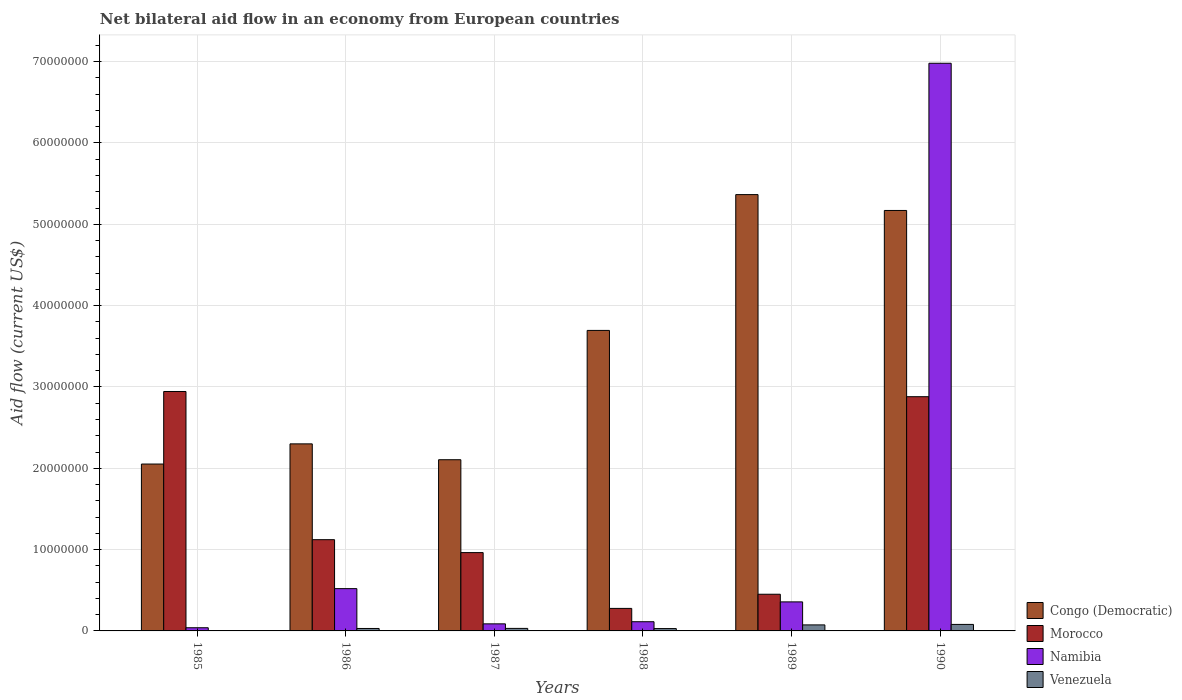How many different coloured bars are there?
Make the answer very short. 4. Are the number of bars per tick equal to the number of legend labels?
Make the answer very short. Yes. Are the number of bars on each tick of the X-axis equal?
Give a very brief answer. Yes. How many bars are there on the 1st tick from the left?
Give a very brief answer. 4. How many bars are there on the 1st tick from the right?
Your response must be concise. 4. What is the label of the 2nd group of bars from the left?
Provide a succinct answer. 1986. In how many cases, is the number of bars for a given year not equal to the number of legend labels?
Provide a short and direct response. 0. What is the net bilateral aid flow in Congo (Democratic) in 1987?
Provide a short and direct response. 2.10e+07. Across all years, what is the maximum net bilateral aid flow in Namibia?
Keep it short and to the point. 6.98e+07. In which year was the net bilateral aid flow in Venezuela maximum?
Offer a terse response. 1990. In which year was the net bilateral aid flow in Congo (Democratic) minimum?
Ensure brevity in your answer.  1985. What is the total net bilateral aid flow in Congo (Democratic) in the graph?
Offer a terse response. 2.07e+08. What is the difference between the net bilateral aid flow in Namibia in 1989 and that in 1990?
Offer a very short reply. -6.62e+07. What is the difference between the net bilateral aid flow in Congo (Democratic) in 1986 and the net bilateral aid flow in Namibia in 1990?
Your answer should be very brief. -4.68e+07. What is the average net bilateral aid flow in Congo (Democratic) per year?
Your answer should be compact. 3.45e+07. In the year 1989, what is the difference between the net bilateral aid flow in Congo (Democratic) and net bilateral aid flow in Venezuela?
Keep it short and to the point. 5.29e+07. In how many years, is the net bilateral aid flow in Namibia greater than 62000000 US$?
Offer a very short reply. 1. What is the ratio of the net bilateral aid flow in Namibia in 1985 to that in 1988?
Give a very brief answer. 0.35. Is the net bilateral aid flow in Namibia in 1987 less than that in 1990?
Ensure brevity in your answer.  Yes. What is the difference between the highest and the second highest net bilateral aid flow in Namibia?
Keep it short and to the point. 6.46e+07. What is the difference between the highest and the lowest net bilateral aid flow in Congo (Democratic)?
Keep it short and to the point. 3.31e+07. Is it the case that in every year, the sum of the net bilateral aid flow in Morocco and net bilateral aid flow in Congo (Democratic) is greater than the sum of net bilateral aid flow in Namibia and net bilateral aid flow in Venezuela?
Offer a terse response. Yes. What does the 4th bar from the left in 1990 represents?
Offer a very short reply. Venezuela. What does the 2nd bar from the right in 1987 represents?
Your answer should be compact. Namibia. Is it the case that in every year, the sum of the net bilateral aid flow in Venezuela and net bilateral aid flow in Morocco is greater than the net bilateral aid flow in Namibia?
Keep it short and to the point. No. Are all the bars in the graph horizontal?
Give a very brief answer. No. What is the difference between two consecutive major ticks on the Y-axis?
Offer a terse response. 1.00e+07. Are the values on the major ticks of Y-axis written in scientific E-notation?
Your answer should be very brief. No. Does the graph contain any zero values?
Give a very brief answer. No. Does the graph contain grids?
Provide a succinct answer. Yes. Where does the legend appear in the graph?
Keep it short and to the point. Bottom right. How many legend labels are there?
Offer a very short reply. 4. How are the legend labels stacked?
Your response must be concise. Vertical. What is the title of the graph?
Provide a succinct answer. Net bilateral aid flow in an economy from European countries. What is the label or title of the X-axis?
Your answer should be compact. Years. What is the Aid flow (current US$) of Congo (Democratic) in 1985?
Provide a succinct answer. 2.05e+07. What is the Aid flow (current US$) in Morocco in 1985?
Ensure brevity in your answer.  2.94e+07. What is the Aid flow (current US$) of Namibia in 1985?
Give a very brief answer. 3.90e+05. What is the Aid flow (current US$) of Congo (Democratic) in 1986?
Your response must be concise. 2.30e+07. What is the Aid flow (current US$) in Morocco in 1986?
Provide a succinct answer. 1.12e+07. What is the Aid flow (current US$) of Namibia in 1986?
Provide a succinct answer. 5.20e+06. What is the Aid flow (current US$) in Venezuela in 1986?
Your answer should be very brief. 3.00e+05. What is the Aid flow (current US$) of Congo (Democratic) in 1987?
Your answer should be compact. 2.10e+07. What is the Aid flow (current US$) of Morocco in 1987?
Make the answer very short. 9.63e+06. What is the Aid flow (current US$) of Namibia in 1987?
Provide a succinct answer. 8.70e+05. What is the Aid flow (current US$) in Congo (Democratic) in 1988?
Your answer should be compact. 3.70e+07. What is the Aid flow (current US$) of Morocco in 1988?
Your answer should be very brief. 2.77e+06. What is the Aid flow (current US$) of Namibia in 1988?
Make the answer very short. 1.13e+06. What is the Aid flow (current US$) in Congo (Democratic) in 1989?
Provide a succinct answer. 5.36e+07. What is the Aid flow (current US$) in Morocco in 1989?
Offer a terse response. 4.51e+06. What is the Aid flow (current US$) of Namibia in 1989?
Keep it short and to the point. 3.57e+06. What is the Aid flow (current US$) of Venezuela in 1989?
Your response must be concise. 7.40e+05. What is the Aid flow (current US$) in Congo (Democratic) in 1990?
Give a very brief answer. 5.17e+07. What is the Aid flow (current US$) of Morocco in 1990?
Keep it short and to the point. 2.88e+07. What is the Aid flow (current US$) in Namibia in 1990?
Ensure brevity in your answer.  6.98e+07. Across all years, what is the maximum Aid flow (current US$) of Congo (Democratic)?
Provide a succinct answer. 5.36e+07. Across all years, what is the maximum Aid flow (current US$) in Morocco?
Offer a very short reply. 2.94e+07. Across all years, what is the maximum Aid flow (current US$) of Namibia?
Provide a short and direct response. 6.98e+07. Across all years, what is the minimum Aid flow (current US$) in Congo (Democratic)?
Your answer should be very brief. 2.05e+07. Across all years, what is the minimum Aid flow (current US$) in Morocco?
Keep it short and to the point. 2.77e+06. Across all years, what is the minimum Aid flow (current US$) in Namibia?
Provide a succinct answer. 3.90e+05. What is the total Aid flow (current US$) of Congo (Democratic) in the graph?
Your answer should be compact. 2.07e+08. What is the total Aid flow (current US$) of Morocco in the graph?
Keep it short and to the point. 8.64e+07. What is the total Aid flow (current US$) in Namibia in the graph?
Offer a very short reply. 8.10e+07. What is the total Aid flow (current US$) in Venezuela in the graph?
Provide a succinct answer. 2.46e+06. What is the difference between the Aid flow (current US$) in Congo (Democratic) in 1985 and that in 1986?
Your response must be concise. -2.48e+06. What is the difference between the Aid flow (current US$) in Morocco in 1985 and that in 1986?
Give a very brief answer. 1.82e+07. What is the difference between the Aid flow (current US$) of Namibia in 1985 and that in 1986?
Offer a very short reply. -4.81e+06. What is the difference between the Aid flow (current US$) of Venezuela in 1985 and that in 1986?
Your answer should be compact. -2.80e+05. What is the difference between the Aid flow (current US$) of Congo (Democratic) in 1985 and that in 1987?
Provide a short and direct response. -5.30e+05. What is the difference between the Aid flow (current US$) of Morocco in 1985 and that in 1987?
Your answer should be compact. 1.98e+07. What is the difference between the Aid flow (current US$) in Namibia in 1985 and that in 1987?
Keep it short and to the point. -4.80e+05. What is the difference between the Aid flow (current US$) of Venezuela in 1985 and that in 1987?
Keep it short and to the point. -2.90e+05. What is the difference between the Aid flow (current US$) in Congo (Democratic) in 1985 and that in 1988?
Give a very brief answer. -1.64e+07. What is the difference between the Aid flow (current US$) in Morocco in 1985 and that in 1988?
Provide a succinct answer. 2.67e+07. What is the difference between the Aid flow (current US$) of Namibia in 1985 and that in 1988?
Your answer should be very brief. -7.40e+05. What is the difference between the Aid flow (current US$) of Congo (Democratic) in 1985 and that in 1989?
Your answer should be compact. -3.31e+07. What is the difference between the Aid flow (current US$) in Morocco in 1985 and that in 1989?
Provide a succinct answer. 2.49e+07. What is the difference between the Aid flow (current US$) in Namibia in 1985 and that in 1989?
Your answer should be very brief. -3.18e+06. What is the difference between the Aid flow (current US$) in Venezuela in 1985 and that in 1989?
Your response must be concise. -7.20e+05. What is the difference between the Aid flow (current US$) of Congo (Democratic) in 1985 and that in 1990?
Offer a very short reply. -3.12e+07. What is the difference between the Aid flow (current US$) of Morocco in 1985 and that in 1990?
Give a very brief answer. 6.40e+05. What is the difference between the Aid flow (current US$) in Namibia in 1985 and that in 1990?
Keep it short and to the point. -6.94e+07. What is the difference between the Aid flow (current US$) of Venezuela in 1985 and that in 1990?
Ensure brevity in your answer.  -7.80e+05. What is the difference between the Aid flow (current US$) of Congo (Democratic) in 1986 and that in 1987?
Provide a succinct answer. 1.95e+06. What is the difference between the Aid flow (current US$) of Morocco in 1986 and that in 1987?
Offer a terse response. 1.59e+06. What is the difference between the Aid flow (current US$) of Namibia in 1986 and that in 1987?
Provide a short and direct response. 4.33e+06. What is the difference between the Aid flow (current US$) of Venezuela in 1986 and that in 1987?
Your answer should be compact. -10000. What is the difference between the Aid flow (current US$) in Congo (Democratic) in 1986 and that in 1988?
Offer a very short reply. -1.40e+07. What is the difference between the Aid flow (current US$) of Morocco in 1986 and that in 1988?
Provide a succinct answer. 8.45e+06. What is the difference between the Aid flow (current US$) in Namibia in 1986 and that in 1988?
Ensure brevity in your answer.  4.07e+06. What is the difference between the Aid flow (current US$) in Congo (Democratic) in 1986 and that in 1989?
Offer a terse response. -3.06e+07. What is the difference between the Aid flow (current US$) of Morocco in 1986 and that in 1989?
Provide a short and direct response. 6.71e+06. What is the difference between the Aid flow (current US$) of Namibia in 1986 and that in 1989?
Offer a terse response. 1.63e+06. What is the difference between the Aid flow (current US$) of Venezuela in 1986 and that in 1989?
Give a very brief answer. -4.40e+05. What is the difference between the Aid flow (current US$) in Congo (Democratic) in 1986 and that in 1990?
Give a very brief answer. -2.87e+07. What is the difference between the Aid flow (current US$) of Morocco in 1986 and that in 1990?
Keep it short and to the point. -1.76e+07. What is the difference between the Aid flow (current US$) of Namibia in 1986 and that in 1990?
Your answer should be compact. -6.46e+07. What is the difference between the Aid flow (current US$) in Venezuela in 1986 and that in 1990?
Give a very brief answer. -5.00e+05. What is the difference between the Aid flow (current US$) in Congo (Democratic) in 1987 and that in 1988?
Make the answer very short. -1.59e+07. What is the difference between the Aid flow (current US$) of Morocco in 1987 and that in 1988?
Provide a succinct answer. 6.86e+06. What is the difference between the Aid flow (current US$) in Congo (Democratic) in 1987 and that in 1989?
Your answer should be compact. -3.26e+07. What is the difference between the Aid flow (current US$) of Morocco in 1987 and that in 1989?
Make the answer very short. 5.12e+06. What is the difference between the Aid flow (current US$) in Namibia in 1987 and that in 1989?
Provide a short and direct response. -2.70e+06. What is the difference between the Aid flow (current US$) in Venezuela in 1987 and that in 1989?
Your response must be concise. -4.30e+05. What is the difference between the Aid flow (current US$) in Congo (Democratic) in 1987 and that in 1990?
Give a very brief answer. -3.06e+07. What is the difference between the Aid flow (current US$) of Morocco in 1987 and that in 1990?
Your response must be concise. -1.92e+07. What is the difference between the Aid flow (current US$) of Namibia in 1987 and that in 1990?
Ensure brevity in your answer.  -6.89e+07. What is the difference between the Aid flow (current US$) of Venezuela in 1987 and that in 1990?
Your answer should be compact. -4.90e+05. What is the difference between the Aid flow (current US$) of Congo (Democratic) in 1988 and that in 1989?
Your answer should be compact. -1.67e+07. What is the difference between the Aid flow (current US$) of Morocco in 1988 and that in 1989?
Offer a very short reply. -1.74e+06. What is the difference between the Aid flow (current US$) of Namibia in 1988 and that in 1989?
Your answer should be very brief. -2.44e+06. What is the difference between the Aid flow (current US$) in Venezuela in 1988 and that in 1989?
Make the answer very short. -4.50e+05. What is the difference between the Aid flow (current US$) of Congo (Democratic) in 1988 and that in 1990?
Your answer should be very brief. -1.48e+07. What is the difference between the Aid flow (current US$) in Morocco in 1988 and that in 1990?
Your answer should be compact. -2.60e+07. What is the difference between the Aid flow (current US$) in Namibia in 1988 and that in 1990?
Your answer should be very brief. -6.87e+07. What is the difference between the Aid flow (current US$) in Venezuela in 1988 and that in 1990?
Offer a terse response. -5.10e+05. What is the difference between the Aid flow (current US$) in Congo (Democratic) in 1989 and that in 1990?
Make the answer very short. 1.95e+06. What is the difference between the Aid flow (current US$) in Morocco in 1989 and that in 1990?
Your answer should be very brief. -2.43e+07. What is the difference between the Aid flow (current US$) in Namibia in 1989 and that in 1990?
Make the answer very short. -6.62e+07. What is the difference between the Aid flow (current US$) of Venezuela in 1989 and that in 1990?
Your answer should be compact. -6.00e+04. What is the difference between the Aid flow (current US$) of Congo (Democratic) in 1985 and the Aid flow (current US$) of Morocco in 1986?
Keep it short and to the point. 9.30e+06. What is the difference between the Aid flow (current US$) of Congo (Democratic) in 1985 and the Aid flow (current US$) of Namibia in 1986?
Ensure brevity in your answer.  1.53e+07. What is the difference between the Aid flow (current US$) in Congo (Democratic) in 1985 and the Aid flow (current US$) in Venezuela in 1986?
Offer a very short reply. 2.02e+07. What is the difference between the Aid flow (current US$) of Morocco in 1985 and the Aid flow (current US$) of Namibia in 1986?
Your answer should be very brief. 2.42e+07. What is the difference between the Aid flow (current US$) of Morocco in 1985 and the Aid flow (current US$) of Venezuela in 1986?
Make the answer very short. 2.91e+07. What is the difference between the Aid flow (current US$) of Congo (Democratic) in 1985 and the Aid flow (current US$) of Morocco in 1987?
Ensure brevity in your answer.  1.09e+07. What is the difference between the Aid flow (current US$) in Congo (Democratic) in 1985 and the Aid flow (current US$) in Namibia in 1987?
Keep it short and to the point. 1.96e+07. What is the difference between the Aid flow (current US$) in Congo (Democratic) in 1985 and the Aid flow (current US$) in Venezuela in 1987?
Your answer should be very brief. 2.02e+07. What is the difference between the Aid flow (current US$) in Morocco in 1985 and the Aid flow (current US$) in Namibia in 1987?
Provide a succinct answer. 2.86e+07. What is the difference between the Aid flow (current US$) of Morocco in 1985 and the Aid flow (current US$) of Venezuela in 1987?
Your answer should be very brief. 2.91e+07. What is the difference between the Aid flow (current US$) of Congo (Democratic) in 1985 and the Aid flow (current US$) of Morocco in 1988?
Provide a short and direct response. 1.78e+07. What is the difference between the Aid flow (current US$) in Congo (Democratic) in 1985 and the Aid flow (current US$) in Namibia in 1988?
Ensure brevity in your answer.  1.94e+07. What is the difference between the Aid flow (current US$) of Congo (Democratic) in 1985 and the Aid flow (current US$) of Venezuela in 1988?
Make the answer very short. 2.02e+07. What is the difference between the Aid flow (current US$) of Morocco in 1985 and the Aid flow (current US$) of Namibia in 1988?
Your response must be concise. 2.83e+07. What is the difference between the Aid flow (current US$) of Morocco in 1985 and the Aid flow (current US$) of Venezuela in 1988?
Ensure brevity in your answer.  2.92e+07. What is the difference between the Aid flow (current US$) in Namibia in 1985 and the Aid flow (current US$) in Venezuela in 1988?
Your answer should be very brief. 1.00e+05. What is the difference between the Aid flow (current US$) of Congo (Democratic) in 1985 and the Aid flow (current US$) of Morocco in 1989?
Provide a short and direct response. 1.60e+07. What is the difference between the Aid flow (current US$) in Congo (Democratic) in 1985 and the Aid flow (current US$) in Namibia in 1989?
Your answer should be very brief. 1.70e+07. What is the difference between the Aid flow (current US$) of Congo (Democratic) in 1985 and the Aid flow (current US$) of Venezuela in 1989?
Your answer should be very brief. 1.98e+07. What is the difference between the Aid flow (current US$) in Morocco in 1985 and the Aid flow (current US$) in Namibia in 1989?
Keep it short and to the point. 2.59e+07. What is the difference between the Aid flow (current US$) of Morocco in 1985 and the Aid flow (current US$) of Venezuela in 1989?
Ensure brevity in your answer.  2.87e+07. What is the difference between the Aid flow (current US$) in Namibia in 1985 and the Aid flow (current US$) in Venezuela in 1989?
Make the answer very short. -3.50e+05. What is the difference between the Aid flow (current US$) of Congo (Democratic) in 1985 and the Aid flow (current US$) of Morocco in 1990?
Make the answer very short. -8.28e+06. What is the difference between the Aid flow (current US$) of Congo (Democratic) in 1985 and the Aid flow (current US$) of Namibia in 1990?
Offer a terse response. -4.93e+07. What is the difference between the Aid flow (current US$) in Congo (Democratic) in 1985 and the Aid flow (current US$) in Venezuela in 1990?
Your response must be concise. 1.97e+07. What is the difference between the Aid flow (current US$) of Morocco in 1985 and the Aid flow (current US$) of Namibia in 1990?
Your answer should be very brief. -4.04e+07. What is the difference between the Aid flow (current US$) in Morocco in 1985 and the Aid flow (current US$) in Venezuela in 1990?
Provide a short and direct response. 2.86e+07. What is the difference between the Aid flow (current US$) of Namibia in 1985 and the Aid flow (current US$) of Venezuela in 1990?
Provide a succinct answer. -4.10e+05. What is the difference between the Aid flow (current US$) of Congo (Democratic) in 1986 and the Aid flow (current US$) of Morocco in 1987?
Provide a succinct answer. 1.34e+07. What is the difference between the Aid flow (current US$) of Congo (Democratic) in 1986 and the Aid flow (current US$) of Namibia in 1987?
Your response must be concise. 2.21e+07. What is the difference between the Aid flow (current US$) in Congo (Democratic) in 1986 and the Aid flow (current US$) in Venezuela in 1987?
Your answer should be compact. 2.27e+07. What is the difference between the Aid flow (current US$) in Morocco in 1986 and the Aid flow (current US$) in Namibia in 1987?
Your response must be concise. 1.04e+07. What is the difference between the Aid flow (current US$) of Morocco in 1986 and the Aid flow (current US$) of Venezuela in 1987?
Offer a terse response. 1.09e+07. What is the difference between the Aid flow (current US$) in Namibia in 1986 and the Aid flow (current US$) in Venezuela in 1987?
Your answer should be compact. 4.89e+06. What is the difference between the Aid flow (current US$) of Congo (Democratic) in 1986 and the Aid flow (current US$) of Morocco in 1988?
Make the answer very short. 2.02e+07. What is the difference between the Aid flow (current US$) of Congo (Democratic) in 1986 and the Aid flow (current US$) of Namibia in 1988?
Your answer should be very brief. 2.19e+07. What is the difference between the Aid flow (current US$) in Congo (Democratic) in 1986 and the Aid flow (current US$) in Venezuela in 1988?
Provide a short and direct response. 2.27e+07. What is the difference between the Aid flow (current US$) of Morocco in 1986 and the Aid flow (current US$) of Namibia in 1988?
Your response must be concise. 1.01e+07. What is the difference between the Aid flow (current US$) of Morocco in 1986 and the Aid flow (current US$) of Venezuela in 1988?
Offer a terse response. 1.09e+07. What is the difference between the Aid flow (current US$) in Namibia in 1986 and the Aid flow (current US$) in Venezuela in 1988?
Keep it short and to the point. 4.91e+06. What is the difference between the Aid flow (current US$) of Congo (Democratic) in 1986 and the Aid flow (current US$) of Morocco in 1989?
Your answer should be very brief. 1.85e+07. What is the difference between the Aid flow (current US$) in Congo (Democratic) in 1986 and the Aid flow (current US$) in Namibia in 1989?
Your answer should be compact. 1.94e+07. What is the difference between the Aid flow (current US$) of Congo (Democratic) in 1986 and the Aid flow (current US$) of Venezuela in 1989?
Your answer should be compact. 2.23e+07. What is the difference between the Aid flow (current US$) in Morocco in 1986 and the Aid flow (current US$) in Namibia in 1989?
Your response must be concise. 7.65e+06. What is the difference between the Aid flow (current US$) in Morocco in 1986 and the Aid flow (current US$) in Venezuela in 1989?
Your response must be concise. 1.05e+07. What is the difference between the Aid flow (current US$) of Namibia in 1986 and the Aid flow (current US$) of Venezuela in 1989?
Give a very brief answer. 4.46e+06. What is the difference between the Aid flow (current US$) in Congo (Democratic) in 1986 and the Aid flow (current US$) in Morocco in 1990?
Provide a short and direct response. -5.80e+06. What is the difference between the Aid flow (current US$) of Congo (Democratic) in 1986 and the Aid flow (current US$) of Namibia in 1990?
Offer a very short reply. -4.68e+07. What is the difference between the Aid flow (current US$) in Congo (Democratic) in 1986 and the Aid flow (current US$) in Venezuela in 1990?
Keep it short and to the point. 2.22e+07. What is the difference between the Aid flow (current US$) of Morocco in 1986 and the Aid flow (current US$) of Namibia in 1990?
Provide a succinct answer. -5.86e+07. What is the difference between the Aid flow (current US$) of Morocco in 1986 and the Aid flow (current US$) of Venezuela in 1990?
Keep it short and to the point. 1.04e+07. What is the difference between the Aid flow (current US$) of Namibia in 1986 and the Aid flow (current US$) of Venezuela in 1990?
Offer a terse response. 4.40e+06. What is the difference between the Aid flow (current US$) in Congo (Democratic) in 1987 and the Aid flow (current US$) in Morocco in 1988?
Provide a succinct answer. 1.83e+07. What is the difference between the Aid flow (current US$) in Congo (Democratic) in 1987 and the Aid flow (current US$) in Namibia in 1988?
Give a very brief answer. 1.99e+07. What is the difference between the Aid flow (current US$) of Congo (Democratic) in 1987 and the Aid flow (current US$) of Venezuela in 1988?
Ensure brevity in your answer.  2.08e+07. What is the difference between the Aid flow (current US$) in Morocco in 1987 and the Aid flow (current US$) in Namibia in 1988?
Provide a succinct answer. 8.50e+06. What is the difference between the Aid flow (current US$) of Morocco in 1987 and the Aid flow (current US$) of Venezuela in 1988?
Make the answer very short. 9.34e+06. What is the difference between the Aid flow (current US$) of Namibia in 1987 and the Aid flow (current US$) of Venezuela in 1988?
Your answer should be compact. 5.80e+05. What is the difference between the Aid flow (current US$) of Congo (Democratic) in 1987 and the Aid flow (current US$) of Morocco in 1989?
Your answer should be compact. 1.65e+07. What is the difference between the Aid flow (current US$) in Congo (Democratic) in 1987 and the Aid flow (current US$) in Namibia in 1989?
Give a very brief answer. 1.75e+07. What is the difference between the Aid flow (current US$) of Congo (Democratic) in 1987 and the Aid flow (current US$) of Venezuela in 1989?
Offer a very short reply. 2.03e+07. What is the difference between the Aid flow (current US$) of Morocco in 1987 and the Aid flow (current US$) of Namibia in 1989?
Provide a succinct answer. 6.06e+06. What is the difference between the Aid flow (current US$) of Morocco in 1987 and the Aid flow (current US$) of Venezuela in 1989?
Ensure brevity in your answer.  8.89e+06. What is the difference between the Aid flow (current US$) of Congo (Democratic) in 1987 and the Aid flow (current US$) of Morocco in 1990?
Your response must be concise. -7.75e+06. What is the difference between the Aid flow (current US$) of Congo (Democratic) in 1987 and the Aid flow (current US$) of Namibia in 1990?
Provide a short and direct response. -4.88e+07. What is the difference between the Aid flow (current US$) in Congo (Democratic) in 1987 and the Aid flow (current US$) in Venezuela in 1990?
Give a very brief answer. 2.02e+07. What is the difference between the Aid flow (current US$) of Morocco in 1987 and the Aid flow (current US$) of Namibia in 1990?
Give a very brief answer. -6.02e+07. What is the difference between the Aid flow (current US$) in Morocco in 1987 and the Aid flow (current US$) in Venezuela in 1990?
Ensure brevity in your answer.  8.83e+06. What is the difference between the Aid flow (current US$) of Namibia in 1987 and the Aid flow (current US$) of Venezuela in 1990?
Keep it short and to the point. 7.00e+04. What is the difference between the Aid flow (current US$) of Congo (Democratic) in 1988 and the Aid flow (current US$) of Morocco in 1989?
Your answer should be compact. 3.24e+07. What is the difference between the Aid flow (current US$) of Congo (Democratic) in 1988 and the Aid flow (current US$) of Namibia in 1989?
Give a very brief answer. 3.34e+07. What is the difference between the Aid flow (current US$) in Congo (Democratic) in 1988 and the Aid flow (current US$) in Venezuela in 1989?
Your answer should be very brief. 3.62e+07. What is the difference between the Aid flow (current US$) of Morocco in 1988 and the Aid flow (current US$) of Namibia in 1989?
Your response must be concise. -8.00e+05. What is the difference between the Aid flow (current US$) in Morocco in 1988 and the Aid flow (current US$) in Venezuela in 1989?
Provide a succinct answer. 2.03e+06. What is the difference between the Aid flow (current US$) in Congo (Democratic) in 1988 and the Aid flow (current US$) in Morocco in 1990?
Your answer should be compact. 8.15e+06. What is the difference between the Aid flow (current US$) in Congo (Democratic) in 1988 and the Aid flow (current US$) in Namibia in 1990?
Ensure brevity in your answer.  -3.28e+07. What is the difference between the Aid flow (current US$) of Congo (Democratic) in 1988 and the Aid flow (current US$) of Venezuela in 1990?
Make the answer very short. 3.62e+07. What is the difference between the Aid flow (current US$) of Morocco in 1988 and the Aid flow (current US$) of Namibia in 1990?
Make the answer very short. -6.70e+07. What is the difference between the Aid flow (current US$) of Morocco in 1988 and the Aid flow (current US$) of Venezuela in 1990?
Make the answer very short. 1.97e+06. What is the difference between the Aid flow (current US$) in Congo (Democratic) in 1989 and the Aid flow (current US$) in Morocco in 1990?
Your response must be concise. 2.48e+07. What is the difference between the Aid flow (current US$) of Congo (Democratic) in 1989 and the Aid flow (current US$) of Namibia in 1990?
Your answer should be very brief. -1.62e+07. What is the difference between the Aid flow (current US$) in Congo (Democratic) in 1989 and the Aid flow (current US$) in Venezuela in 1990?
Ensure brevity in your answer.  5.28e+07. What is the difference between the Aid flow (current US$) in Morocco in 1989 and the Aid flow (current US$) in Namibia in 1990?
Keep it short and to the point. -6.53e+07. What is the difference between the Aid flow (current US$) of Morocco in 1989 and the Aid flow (current US$) of Venezuela in 1990?
Your answer should be very brief. 3.71e+06. What is the difference between the Aid flow (current US$) in Namibia in 1989 and the Aid flow (current US$) in Venezuela in 1990?
Your answer should be very brief. 2.77e+06. What is the average Aid flow (current US$) of Congo (Democratic) per year?
Offer a very short reply. 3.45e+07. What is the average Aid flow (current US$) of Morocco per year?
Your answer should be very brief. 1.44e+07. What is the average Aid flow (current US$) in Namibia per year?
Give a very brief answer. 1.35e+07. In the year 1985, what is the difference between the Aid flow (current US$) in Congo (Democratic) and Aid flow (current US$) in Morocco?
Ensure brevity in your answer.  -8.92e+06. In the year 1985, what is the difference between the Aid flow (current US$) of Congo (Democratic) and Aid flow (current US$) of Namibia?
Ensure brevity in your answer.  2.01e+07. In the year 1985, what is the difference between the Aid flow (current US$) of Congo (Democratic) and Aid flow (current US$) of Venezuela?
Ensure brevity in your answer.  2.05e+07. In the year 1985, what is the difference between the Aid flow (current US$) in Morocco and Aid flow (current US$) in Namibia?
Your answer should be very brief. 2.90e+07. In the year 1985, what is the difference between the Aid flow (current US$) in Morocco and Aid flow (current US$) in Venezuela?
Make the answer very short. 2.94e+07. In the year 1986, what is the difference between the Aid flow (current US$) of Congo (Democratic) and Aid flow (current US$) of Morocco?
Offer a very short reply. 1.18e+07. In the year 1986, what is the difference between the Aid flow (current US$) in Congo (Democratic) and Aid flow (current US$) in Namibia?
Your response must be concise. 1.78e+07. In the year 1986, what is the difference between the Aid flow (current US$) of Congo (Democratic) and Aid flow (current US$) of Venezuela?
Your answer should be compact. 2.27e+07. In the year 1986, what is the difference between the Aid flow (current US$) of Morocco and Aid flow (current US$) of Namibia?
Offer a terse response. 6.02e+06. In the year 1986, what is the difference between the Aid flow (current US$) in Morocco and Aid flow (current US$) in Venezuela?
Provide a short and direct response. 1.09e+07. In the year 1986, what is the difference between the Aid flow (current US$) of Namibia and Aid flow (current US$) of Venezuela?
Provide a succinct answer. 4.90e+06. In the year 1987, what is the difference between the Aid flow (current US$) in Congo (Democratic) and Aid flow (current US$) in Morocco?
Your answer should be very brief. 1.14e+07. In the year 1987, what is the difference between the Aid flow (current US$) in Congo (Democratic) and Aid flow (current US$) in Namibia?
Make the answer very short. 2.02e+07. In the year 1987, what is the difference between the Aid flow (current US$) in Congo (Democratic) and Aid flow (current US$) in Venezuela?
Provide a succinct answer. 2.07e+07. In the year 1987, what is the difference between the Aid flow (current US$) in Morocco and Aid flow (current US$) in Namibia?
Ensure brevity in your answer.  8.76e+06. In the year 1987, what is the difference between the Aid flow (current US$) in Morocco and Aid flow (current US$) in Venezuela?
Make the answer very short. 9.32e+06. In the year 1987, what is the difference between the Aid flow (current US$) in Namibia and Aid flow (current US$) in Venezuela?
Give a very brief answer. 5.60e+05. In the year 1988, what is the difference between the Aid flow (current US$) of Congo (Democratic) and Aid flow (current US$) of Morocco?
Provide a short and direct response. 3.42e+07. In the year 1988, what is the difference between the Aid flow (current US$) of Congo (Democratic) and Aid flow (current US$) of Namibia?
Keep it short and to the point. 3.58e+07. In the year 1988, what is the difference between the Aid flow (current US$) of Congo (Democratic) and Aid flow (current US$) of Venezuela?
Your answer should be very brief. 3.67e+07. In the year 1988, what is the difference between the Aid flow (current US$) in Morocco and Aid flow (current US$) in Namibia?
Your answer should be compact. 1.64e+06. In the year 1988, what is the difference between the Aid flow (current US$) in Morocco and Aid flow (current US$) in Venezuela?
Your answer should be compact. 2.48e+06. In the year 1988, what is the difference between the Aid flow (current US$) of Namibia and Aid flow (current US$) of Venezuela?
Provide a short and direct response. 8.40e+05. In the year 1989, what is the difference between the Aid flow (current US$) of Congo (Democratic) and Aid flow (current US$) of Morocco?
Offer a terse response. 4.91e+07. In the year 1989, what is the difference between the Aid flow (current US$) of Congo (Democratic) and Aid flow (current US$) of Namibia?
Your answer should be compact. 5.01e+07. In the year 1989, what is the difference between the Aid flow (current US$) of Congo (Democratic) and Aid flow (current US$) of Venezuela?
Your answer should be very brief. 5.29e+07. In the year 1989, what is the difference between the Aid flow (current US$) in Morocco and Aid flow (current US$) in Namibia?
Your response must be concise. 9.40e+05. In the year 1989, what is the difference between the Aid flow (current US$) in Morocco and Aid flow (current US$) in Venezuela?
Make the answer very short. 3.77e+06. In the year 1989, what is the difference between the Aid flow (current US$) of Namibia and Aid flow (current US$) of Venezuela?
Ensure brevity in your answer.  2.83e+06. In the year 1990, what is the difference between the Aid flow (current US$) of Congo (Democratic) and Aid flow (current US$) of Morocco?
Give a very brief answer. 2.29e+07. In the year 1990, what is the difference between the Aid flow (current US$) of Congo (Democratic) and Aid flow (current US$) of Namibia?
Provide a short and direct response. -1.81e+07. In the year 1990, what is the difference between the Aid flow (current US$) of Congo (Democratic) and Aid flow (current US$) of Venezuela?
Provide a succinct answer. 5.09e+07. In the year 1990, what is the difference between the Aid flow (current US$) of Morocco and Aid flow (current US$) of Namibia?
Offer a terse response. -4.10e+07. In the year 1990, what is the difference between the Aid flow (current US$) in Morocco and Aid flow (current US$) in Venezuela?
Keep it short and to the point. 2.80e+07. In the year 1990, what is the difference between the Aid flow (current US$) of Namibia and Aid flow (current US$) of Venezuela?
Provide a short and direct response. 6.90e+07. What is the ratio of the Aid flow (current US$) in Congo (Democratic) in 1985 to that in 1986?
Make the answer very short. 0.89. What is the ratio of the Aid flow (current US$) of Morocco in 1985 to that in 1986?
Your answer should be compact. 2.62. What is the ratio of the Aid flow (current US$) in Namibia in 1985 to that in 1986?
Make the answer very short. 0.07. What is the ratio of the Aid flow (current US$) in Venezuela in 1985 to that in 1986?
Keep it short and to the point. 0.07. What is the ratio of the Aid flow (current US$) in Congo (Democratic) in 1985 to that in 1987?
Provide a succinct answer. 0.97. What is the ratio of the Aid flow (current US$) of Morocco in 1985 to that in 1987?
Your answer should be very brief. 3.06. What is the ratio of the Aid flow (current US$) in Namibia in 1985 to that in 1987?
Offer a terse response. 0.45. What is the ratio of the Aid flow (current US$) in Venezuela in 1985 to that in 1987?
Keep it short and to the point. 0.06. What is the ratio of the Aid flow (current US$) in Congo (Democratic) in 1985 to that in 1988?
Provide a succinct answer. 0.56. What is the ratio of the Aid flow (current US$) in Morocco in 1985 to that in 1988?
Offer a terse response. 10.63. What is the ratio of the Aid flow (current US$) in Namibia in 1985 to that in 1988?
Make the answer very short. 0.35. What is the ratio of the Aid flow (current US$) in Venezuela in 1985 to that in 1988?
Make the answer very short. 0.07. What is the ratio of the Aid flow (current US$) of Congo (Democratic) in 1985 to that in 1989?
Offer a very short reply. 0.38. What is the ratio of the Aid flow (current US$) of Morocco in 1985 to that in 1989?
Give a very brief answer. 6.53. What is the ratio of the Aid flow (current US$) in Namibia in 1985 to that in 1989?
Provide a succinct answer. 0.11. What is the ratio of the Aid flow (current US$) in Venezuela in 1985 to that in 1989?
Provide a short and direct response. 0.03. What is the ratio of the Aid flow (current US$) of Congo (Democratic) in 1985 to that in 1990?
Provide a succinct answer. 0.4. What is the ratio of the Aid flow (current US$) of Morocco in 1985 to that in 1990?
Your answer should be compact. 1.02. What is the ratio of the Aid flow (current US$) of Namibia in 1985 to that in 1990?
Your answer should be very brief. 0.01. What is the ratio of the Aid flow (current US$) of Venezuela in 1985 to that in 1990?
Give a very brief answer. 0.03. What is the ratio of the Aid flow (current US$) of Congo (Democratic) in 1986 to that in 1987?
Ensure brevity in your answer.  1.09. What is the ratio of the Aid flow (current US$) of Morocco in 1986 to that in 1987?
Your response must be concise. 1.17. What is the ratio of the Aid flow (current US$) in Namibia in 1986 to that in 1987?
Your answer should be compact. 5.98. What is the ratio of the Aid flow (current US$) in Venezuela in 1986 to that in 1987?
Offer a very short reply. 0.97. What is the ratio of the Aid flow (current US$) in Congo (Democratic) in 1986 to that in 1988?
Ensure brevity in your answer.  0.62. What is the ratio of the Aid flow (current US$) of Morocco in 1986 to that in 1988?
Provide a short and direct response. 4.05. What is the ratio of the Aid flow (current US$) in Namibia in 1986 to that in 1988?
Ensure brevity in your answer.  4.6. What is the ratio of the Aid flow (current US$) in Venezuela in 1986 to that in 1988?
Provide a succinct answer. 1.03. What is the ratio of the Aid flow (current US$) of Congo (Democratic) in 1986 to that in 1989?
Your answer should be very brief. 0.43. What is the ratio of the Aid flow (current US$) of Morocco in 1986 to that in 1989?
Give a very brief answer. 2.49. What is the ratio of the Aid flow (current US$) of Namibia in 1986 to that in 1989?
Ensure brevity in your answer.  1.46. What is the ratio of the Aid flow (current US$) of Venezuela in 1986 to that in 1989?
Give a very brief answer. 0.41. What is the ratio of the Aid flow (current US$) of Congo (Democratic) in 1986 to that in 1990?
Give a very brief answer. 0.44. What is the ratio of the Aid flow (current US$) in Morocco in 1986 to that in 1990?
Provide a succinct answer. 0.39. What is the ratio of the Aid flow (current US$) of Namibia in 1986 to that in 1990?
Provide a short and direct response. 0.07. What is the ratio of the Aid flow (current US$) in Venezuela in 1986 to that in 1990?
Give a very brief answer. 0.38. What is the ratio of the Aid flow (current US$) in Congo (Democratic) in 1987 to that in 1988?
Make the answer very short. 0.57. What is the ratio of the Aid flow (current US$) of Morocco in 1987 to that in 1988?
Make the answer very short. 3.48. What is the ratio of the Aid flow (current US$) in Namibia in 1987 to that in 1988?
Give a very brief answer. 0.77. What is the ratio of the Aid flow (current US$) in Venezuela in 1987 to that in 1988?
Your response must be concise. 1.07. What is the ratio of the Aid flow (current US$) of Congo (Democratic) in 1987 to that in 1989?
Give a very brief answer. 0.39. What is the ratio of the Aid flow (current US$) in Morocco in 1987 to that in 1989?
Give a very brief answer. 2.14. What is the ratio of the Aid flow (current US$) in Namibia in 1987 to that in 1989?
Your answer should be compact. 0.24. What is the ratio of the Aid flow (current US$) of Venezuela in 1987 to that in 1989?
Provide a short and direct response. 0.42. What is the ratio of the Aid flow (current US$) in Congo (Democratic) in 1987 to that in 1990?
Offer a terse response. 0.41. What is the ratio of the Aid flow (current US$) of Morocco in 1987 to that in 1990?
Your answer should be compact. 0.33. What is the ratio of the Aid flow (current US$) of Namibia in 1987 to that in 1990?
Offer a very short reply. 0.01. What is the ratio of the Aid flow (current US$) in Venezuela in 1987 to that in 1990?
Offer a very short reply. 0.39. What is the ratio of the Aid flow (current US$) of Congo (Democratic) in 1988 to that in 1989?
Your answer should be very brief. 0.69. What is the ratio of the Aid flow (current US$) of Morocco in 1988 to that in 1989?
Offer a terse response. 0.61. What is the ratio of the Aid flow (current US$) of Namibia in 1988 to that in 1989?
Your answer should be very brief. 0.32. What is the ratio of the Aid flow (current US$) of Venezuela in 1988 to that in 1989?
Provide a short and direct response. 0.39. What is the ratio of the Aid flow (current US$) in Congo (Democratic) in 1988 to that in 1990?
Provide a succinct answer. 0.71. What is the ratio of the Aid flow (current US$) of Morocco in 1988 to that in 1990?
Keep it short and to the point. 0.1. What is the ratio of the Aid flow (current US$) in Namibia in 1988 to that in 1990?
Provide a succinct answer. 0.02. What is the ratio of the Aid flow (current US$) in Venezuela in 1988 to that in 1990?
Your answer should be compact. 0.36. What is the ratio of the Aid flow (current US$) of Congo (Democratic) in 1989 to that in 1990?
Give a very brief answer. 1.04. What is the ratio of the Aid flow (current US$) of Morocco in 1989 to that in 1990?
Provide a succinct answer. 0.16. What is the ratio of the Aid flow (current US$) of Namibia in 1989 to that in 1990?
Provide a succinct answer. 0.05. What is the ratio of the Aid flow (current US$) of Venezuela in 1989 to that in 1990?
Keep it short and to the point. 0.93. What is the difference between the highest and the second highest Aid flow (current US$) of Congo (Democratic)?
Provide a short and direct response. 1.95e+06. What is the difference between the highest and the second highest Aid flow (current US$) in Morocco?
Give a very brief answer. 6.40e+05. What is the difference between the highest and the second highest Aid flow (current US$) of Namibia?
Give a very brief answer. 6.46e+07. What is the difference between the highest and the second highest Aid flow (current US$) in Venezuela?
Provide a succinct answer. 6.00e+04. What is the difference between the highest and the lowest Aid flow (current US$) of Congo (Democratic)?
Provide a short and direct response. 3.31e+07. What is the difference between the highest and the lowest Aid flow (current US$) of Morocco?
Your response must be concise. 2.67e+07. What is the difference between the highest and the lowest Aid flow (current US$) of Namibia?
Make the answer very short. 6.94e+07. What is the difference between the highest and the lowest Aid flow (current US$) in Venezuela?
Keep it short and to the point. 7.80e+05. 